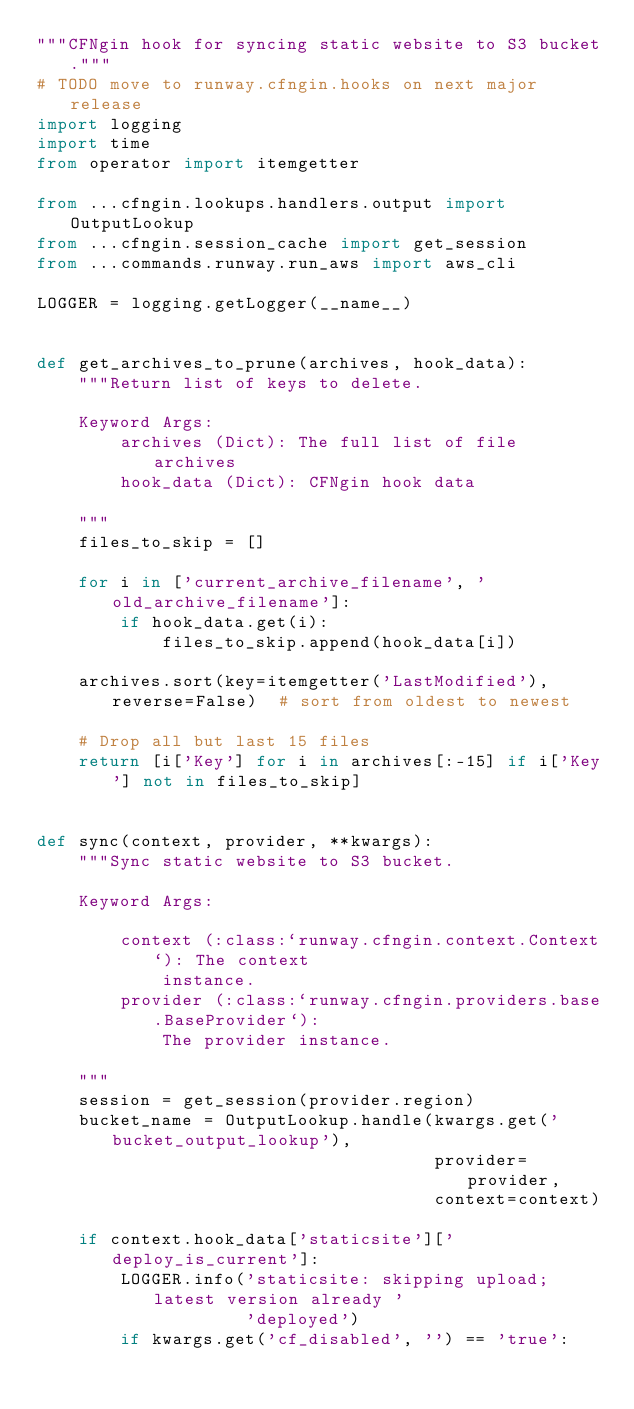Convert code to text. <code><loc_0><loc_0><loc_500><loc_500><_Python_>"""CFNgin hook for syncing static website to S3 bucket."""
# TODO move to runway.cfngin.hooks on next major release
import logging
import time
from operator import itemgetter

from ...cfngin.lookups.handlers.output import OutputLookup
from ...cfngin.session_cache import get_session
from ...commands.runway.run_aws import aws_cli

LOGGER = logging.getLogger(__name__)


def get_archives_to_prune(archives, hook_data):
    """Return list of keys to delete.

    Keyword Args:
        archives (Dict): The full list of file archives
        hook_data (Dict): CFNgin hook data

    """
    files_to_skip = []

    for i in ['current_archive_filename', 'old_archive_filename']:
        if hook_data.get(i):
            files_to_skip.append(hook_data[i])

    archives.sort(key=itemgetter('LastModified'), reverse=False)  # sort from oldest to newest

    # Drop all but last 15 files
    return [i['Key'] for i in archives[:-15] if i['Key'] not in files_to_skip]


def sync(context, provider, **kwargs):
    """Sync static website to S3 bucket.

    Keyword Args:

        context (:class:`runway.cfngin.context.Context`): The context
            instance.
        provider (:class:`runway.cfngin.providers.base.BaseProvider`):
            The provider instance.

    """
    session = get_session(provider.region)
    bucket_name = OutputLookup.handle(kwargs.get('bucket_output_lookup'),
                                      provider=provider,
                                      context=context)

    if context.hook_data['staticsite']['deploy_is_current']:
        LOGGER.info('staticsite: skipping upload; latest version already '
                    'deployed')
        if kwargs.get('cf_disabled', '') == 'true':</code> 